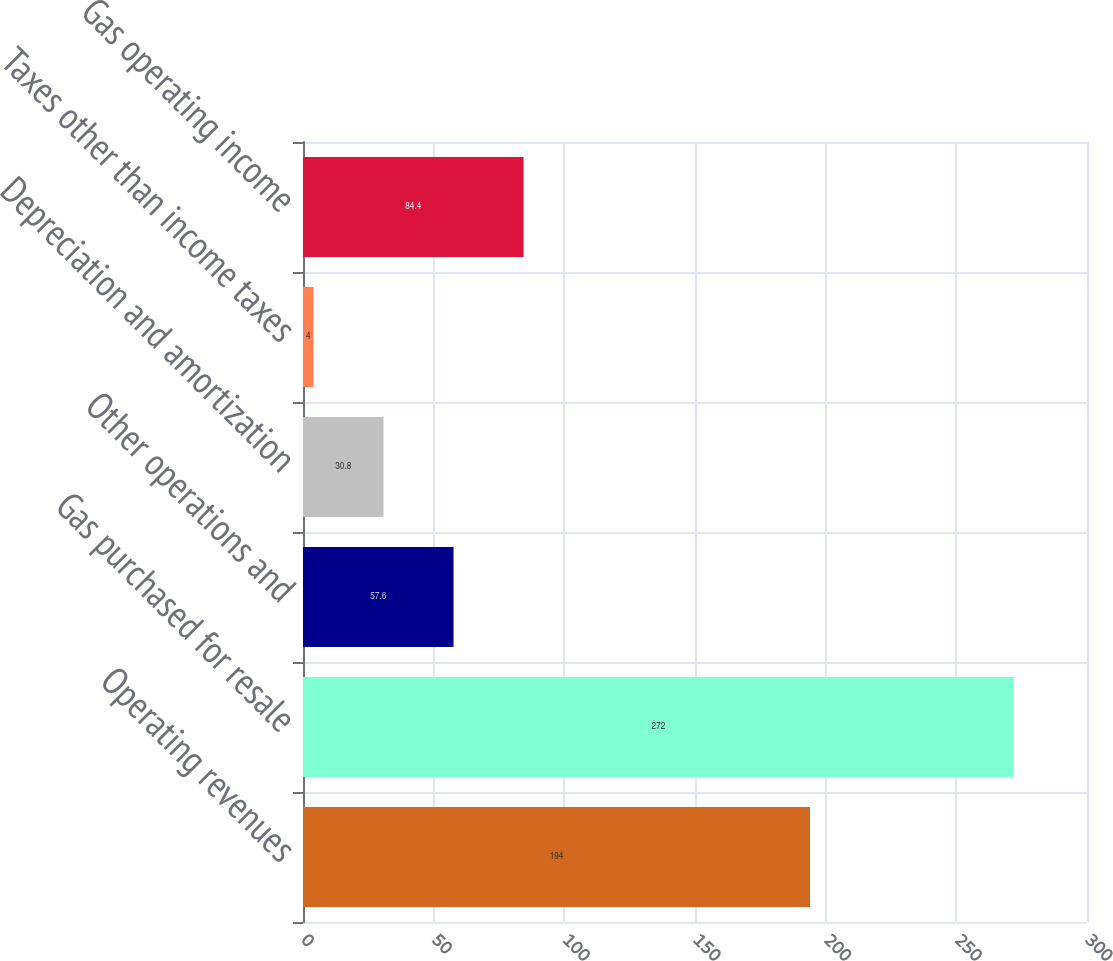<chart> <loc_0><loc_0><loc_500><loc_500><bar_chart><fcel>Operating revenues<fcel>Gas purchased for resale<fcel>Other operations and<fcel>Depreciation and amortization<fcel>Taxes other than income taxes<fcel>Gas operating income<nl><fcel>194<fcel>272<fcel>57.6<fcel>30.8<fcel>4<fcel>84.4<nl></chart> 